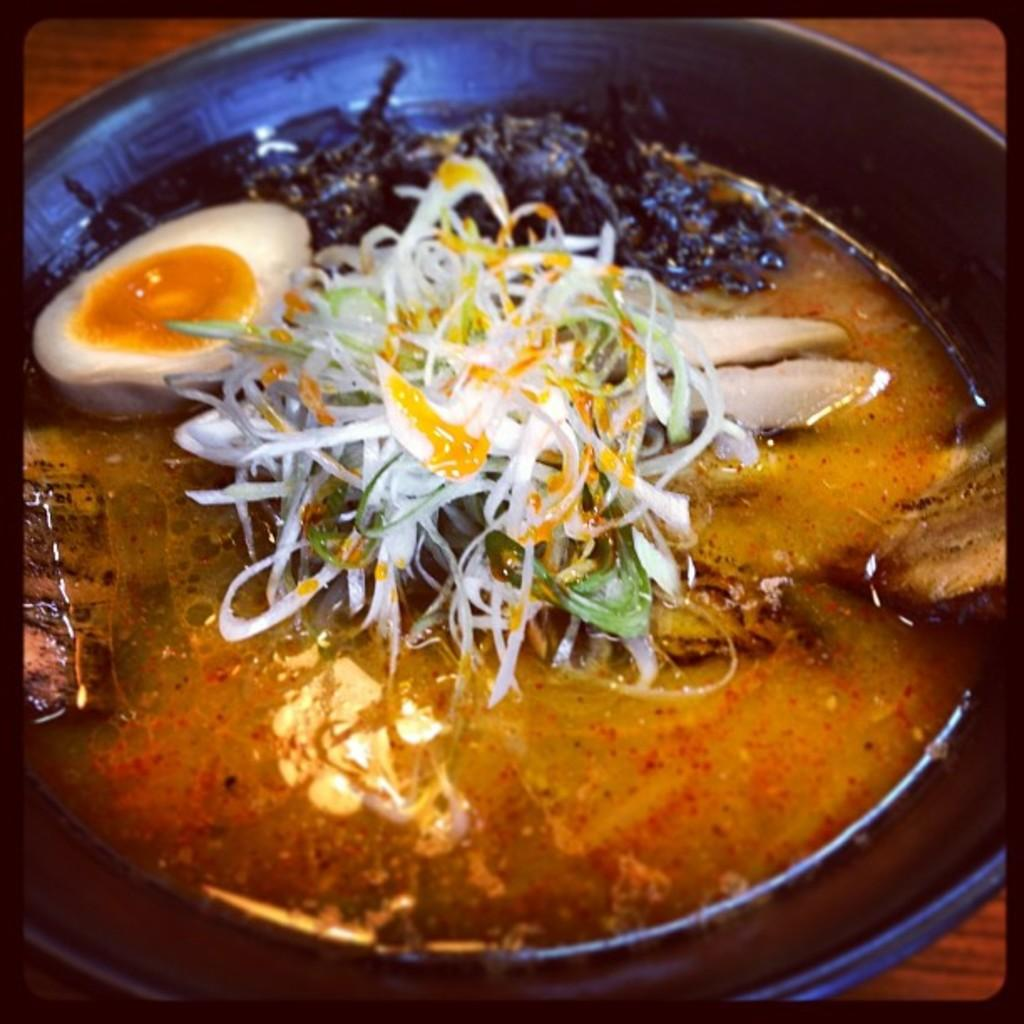What type of pan is visible in the image? There is a black pan in the image. What is inside the pan? The pan contains food with egg. Where is the pan placed? The pan is placed on a wooden table top. What type of flooring is visible beneath the table in the image? The provided facts do not mention the flooring beneath the table, so it cannot be determined from the image. 